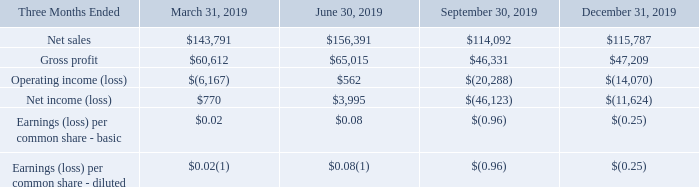Note 19 – Summarized Quarterly Financial Data (Unaudited)
The following table presents unaudited quarterly operating results for each of our last eight fiscal quarters. This information has been prepared on a basis consistent with our audited financial statements and includes all adjustments, consisting only of normal recurring adjustments, considered necessary for a fair presentation of the data.
UNAUDITED QUARTERLY OPERATING RESULTS
(In thousands, except for per share amounts)
(1) Assumes exercise of dilutive securities calculated under the treasury stock method.
What was the net sales in Three Months Ended March 31, 2019?
Answer scale should be: thousand. $143,791. What was the Gross Profit in Three Months Ended June 30, 2019?
Answer scale should be: thousand. $65,015. What does the table show? Unaudited quarterly operating results. What is the total net sales of the 3 highest earning quarters in 2019?
Answer scale should be: thousand.  $143,791 + $156,391 + $115,787 
Answer: 415969. What was the change in gross profit between  Three Months Ended  March 31, 2019 and June 30, 2019?
Answer scale should be: thousand. $65,015-$60,612
Answer: 4403. What was the percentage change in Net sales between Three Months Ended  September and December in 2019?
Answer scale should be: percent. ( $115,787 - $114,092 )/ $114,092 
Answer: 1.49. 